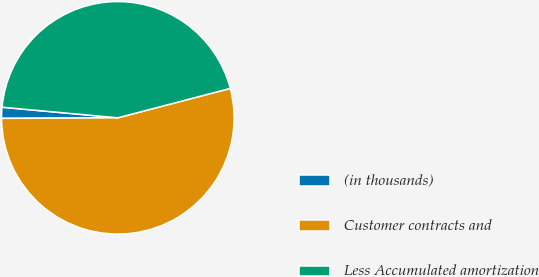<chart> <loc_0><loc_0><loc_500><loc_500><pie_chart><fcel>(in thousands)<fcel>Customer contracts and<fcel>Less Accumulated amortization<nl><fcel>1.53%<fcel>54.0%<fcel>44.48%<nl></chart> 